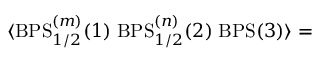Convert formula to latex. <formula><loc_0><loc_0><loc_500><loc_500>\langle B P S _ { 1 / 2 } ^ { ( m ) } ( 1 ) \, B P S _ { 1 / 2 } ^ { ( n ) } ( 2 ) \, B P S ( 3 ) \rangle =</formula> 